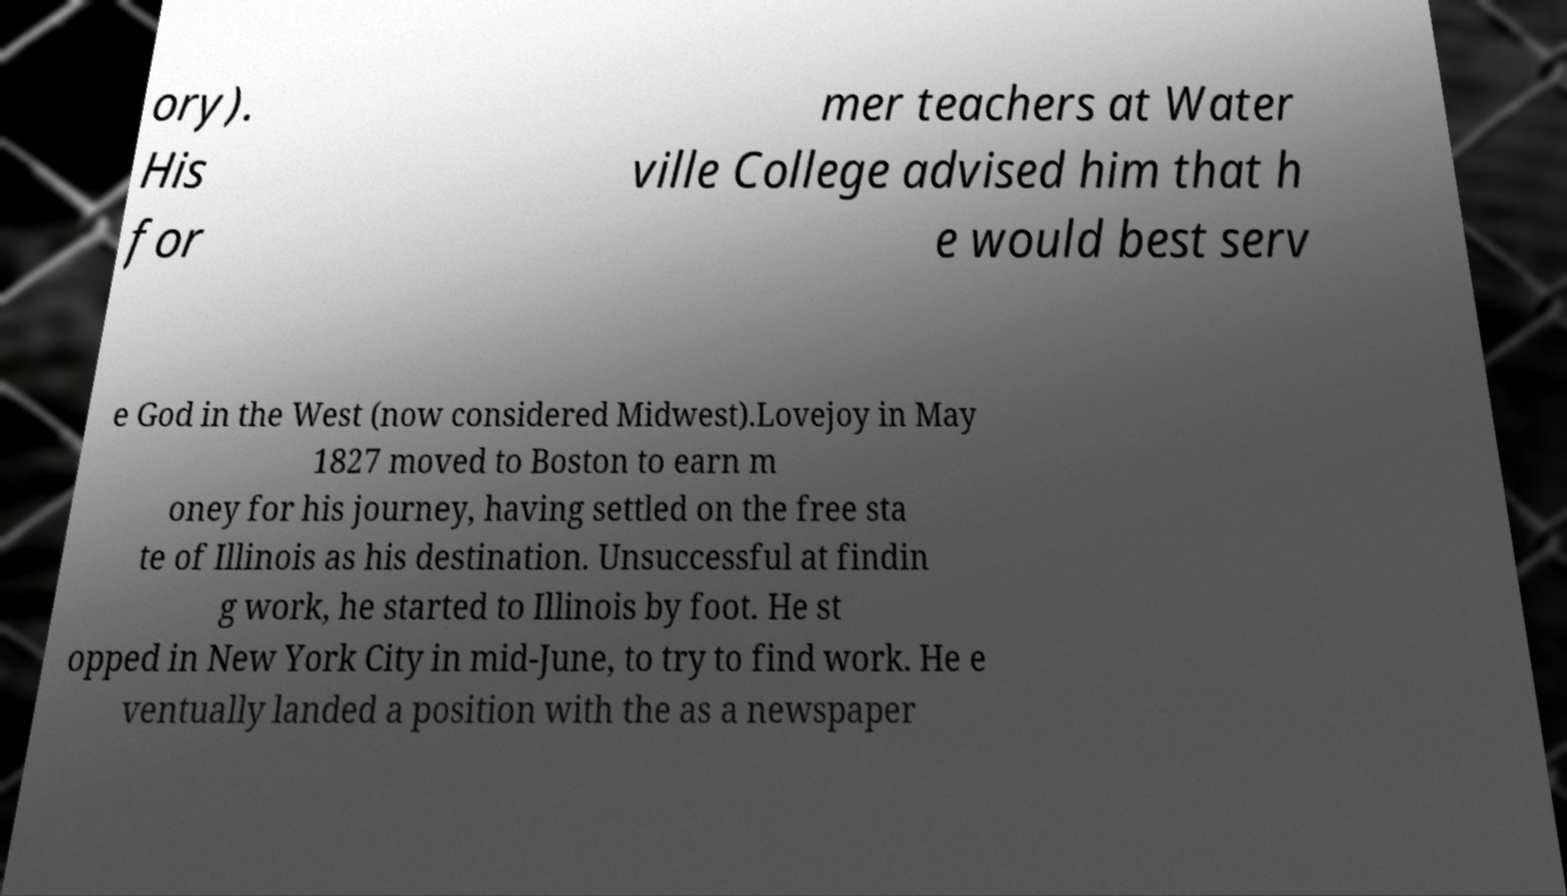I need the written content from this picture converted into text. Can you do that? ory). His for mer teachers at Water ville College advised him that h e would best serv e God in the West (now considered Midwest).Lovejoy in May 1827 moved to Boston to earn m oney for his journey, having settled on the free sta te of Illinois as his destination. Unsuccessful at findin g work, he started to Illinois by foot. He st opped in New York City in mid-June, to try to find work. He e ventually landed a position with the as a newspaper 